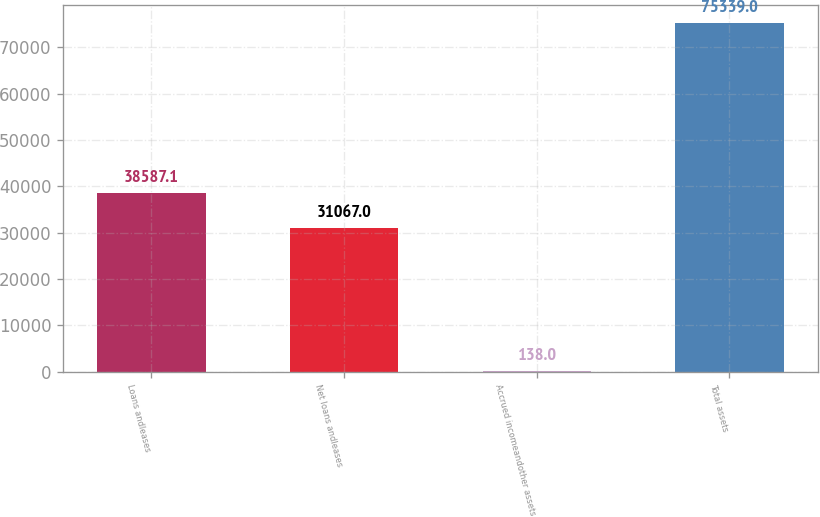Convert chart to OTSL. <chart><loc_0><loc_0><loc_500><loc_500><bar_chart><fcel>Loans andleases<fcel>Net loans andleases<fcel>Accrued incomeandother assets<fcel>Total assets<nl><fcel>38587.1<fcel>31067<fcel>138<fcel>75339<nl></chart> 